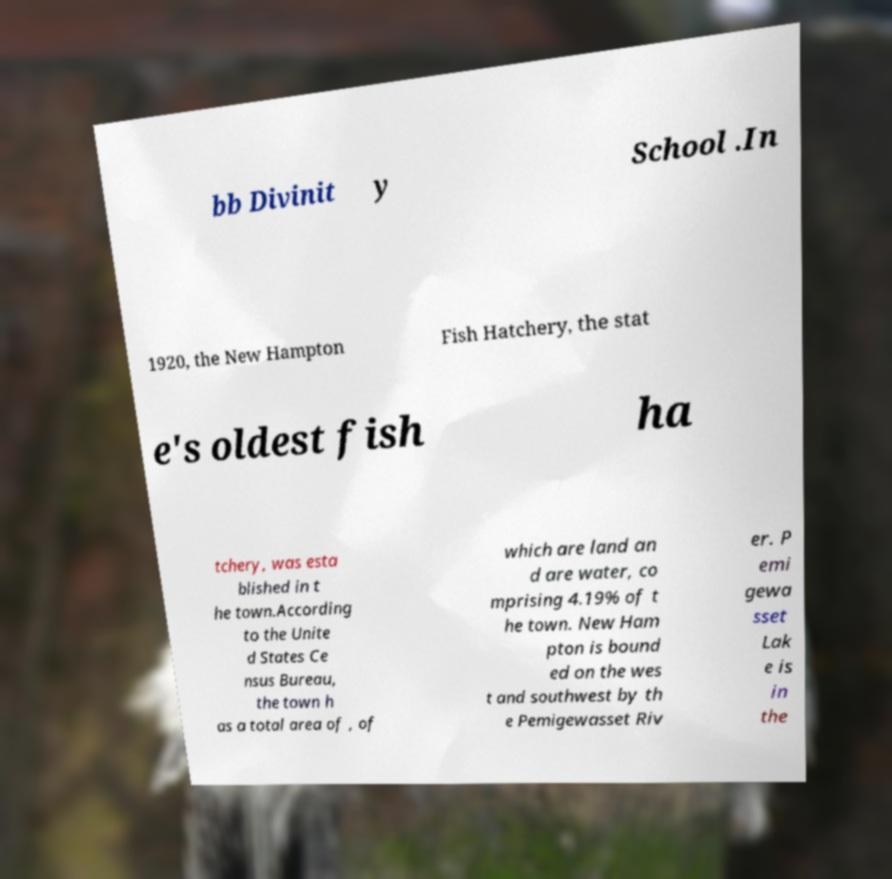Could you extract and type out the text from this image? bb Divinit y School .In 1920, the New Hampton Fish Hatchery, the stat e's oldest fish ha tchery, was esta blished in t he town.According to the Unite d States Ce nsus Bureau, the town h as a total area of , of which are land an d are water, co mprising 4.19% of t he town. New Ham pton is bound ed on the wes t and southwest by th e Pemigewasset Riv er. P emi gewa sset Lak e is in the 